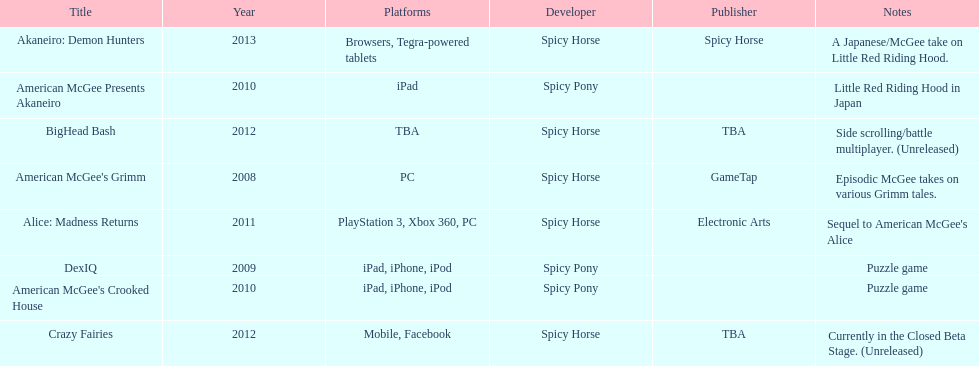Would you be able to parse every entry in this table? {'header': ['Title', 'Year', 'Platforms', 'Developer', 'Publisher', 'Notes'], 'rows': [['Akaneiro: Demon Hunters', '2013', 'Browsers, Tegra-powered tablets', 'Spicy Horse', 'Spicy Horse', 'A Japanese/McGee take on Little Red Riding Hood.'], ['American McGee Presents Akaneiro', '2010', 'iPad', 'Spicy Pony', '', 'Little Red Riding Hood in Japan'], ['BigHead Bash', '2012', 'TBA', 'Spicy Horse', 'TBA', 'Side scrolling/battle multiplayer. (Unreleased)'], ["American McGee's Grimm", '2008', 'PC', 'Spicy Horse', 'GameTap', 'Episodic McGee takes on various Grimm tales.'], ['Alice: Madness Returns', '2011', 'PlayStation 3, Xbox 360, PC', 'Spicy Horse', 'Electronic Arts', "Sequel to American McGee's Alice"], ['DexIQ', '2009', 'iPad, iPhone, iPod', 'Spicy Pony', '', 'Puzzle game'], ["American McGee's Crooked House", '2010', 'iPad, iPhone, iPod', 'Spicy Pony', '', 'Puzzle game'], ['Crazy Fairies', '2012', 'Mobile, Facebook', 'Spicy Horse', 'TBA', 'Currently in the Closed Beta Stage. (Unreleased)']]} How many platforms did american mcgee's grimm run on? 1. 